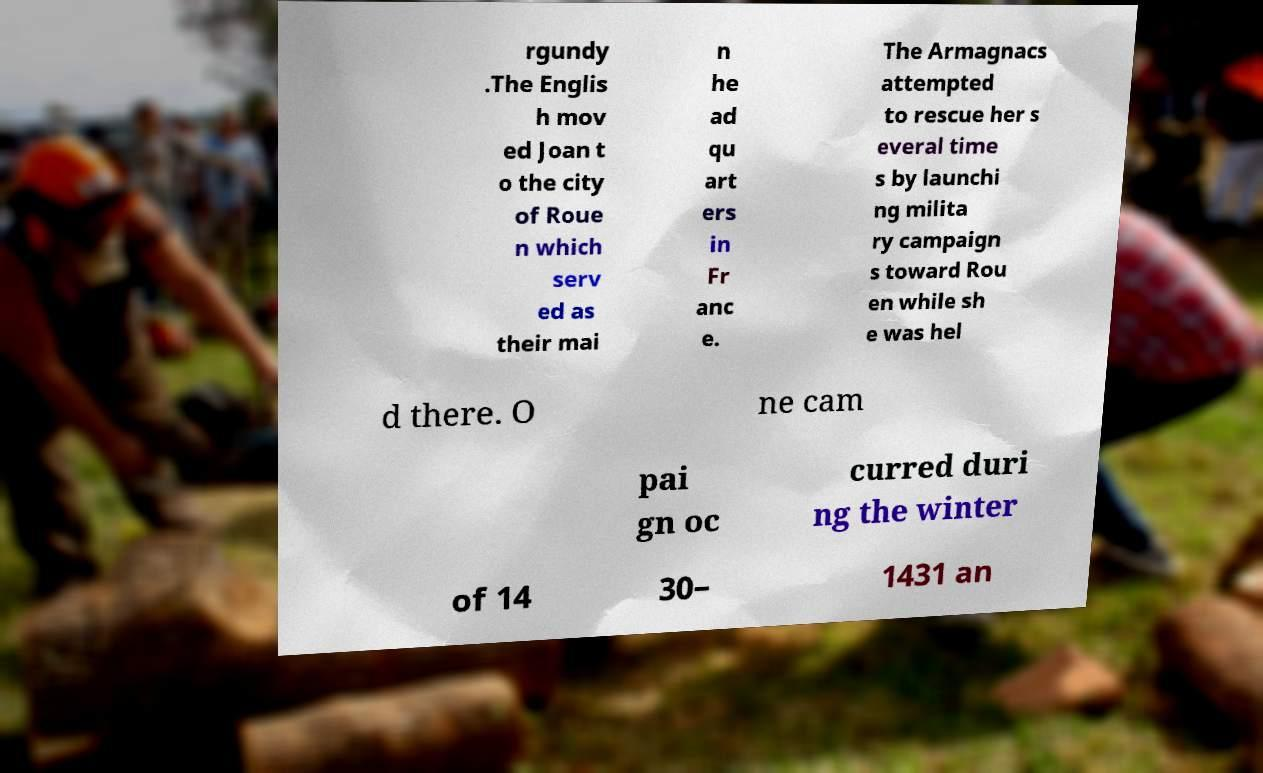Could you assist in decoding the text presented in this image and type it out clearly? rgundy .The Englis h mov ed Joan t o the city of Roue n which serv ed as their mai n he ad qu art ers in Fr anc e. The Armagnacs attempted to rescue her s everal time s by launchi ng milita ry campaign s toward Rou en while sh e was hel d there. O ne cam pai gn oc curred duri ng the winter of 14 30– 1431 an 